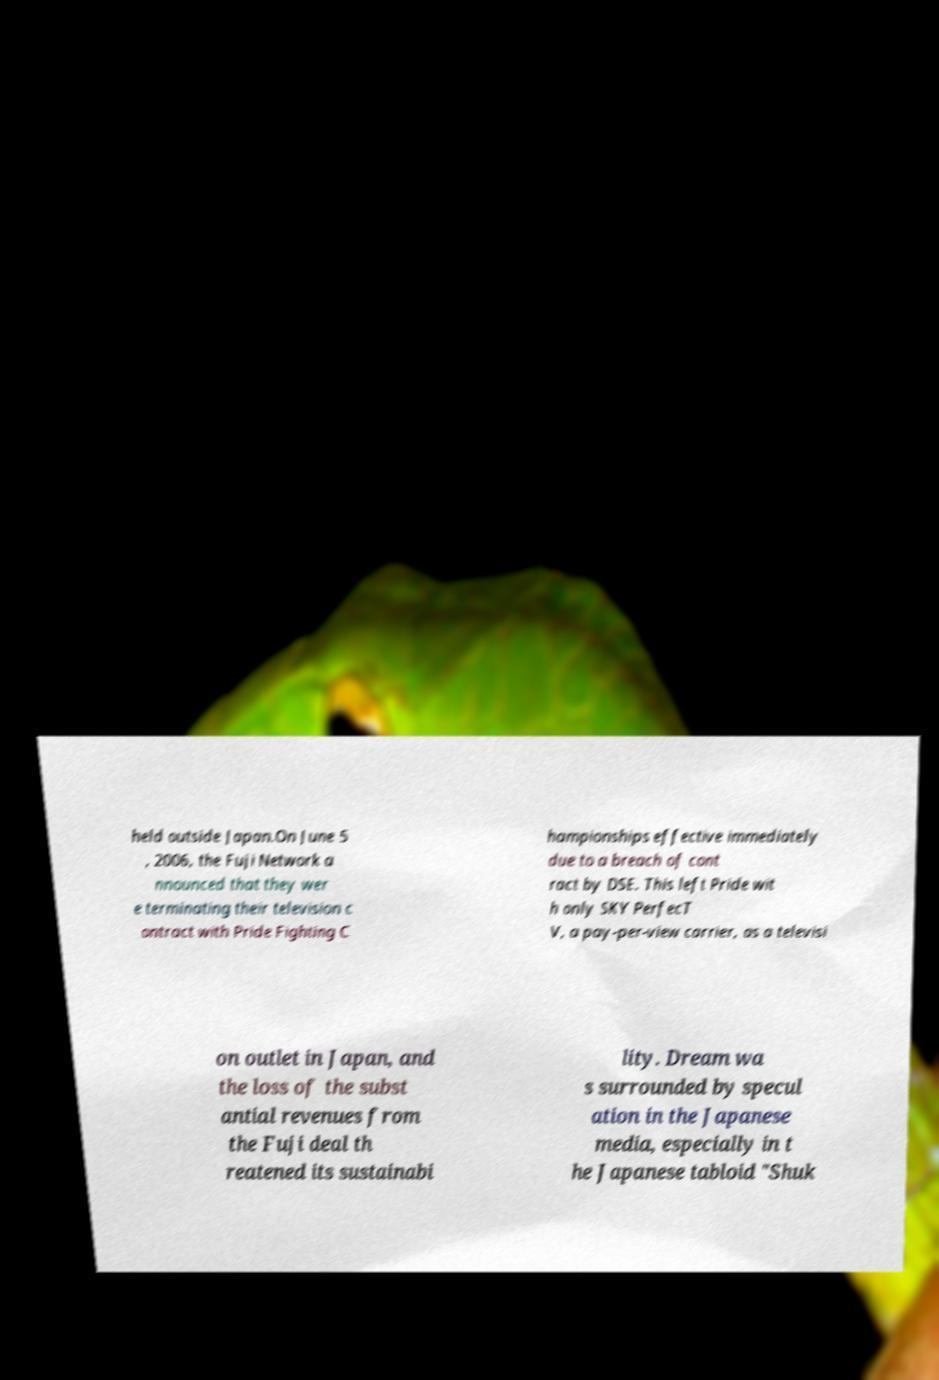Please identify and transcribe the text found in this image. held outside Japan.On June 5 , 2006, the Fuji Network a nnounced that they wer e terminating their television c ontract with Pride Fighting C hampionships effective immediately due to a breach of cont ract by DSE. This left Pride wit h only SKY PerfecT V, a pay-per-view carrier, as a televisi on outlet in Japan, and the loss of the subst antial revenues from the Fuji deal th reatened its sustainabi lity. Dream wa s surrounded by specul ation in the Japanese media, especially in t he Japanese tabloid "Shuk 